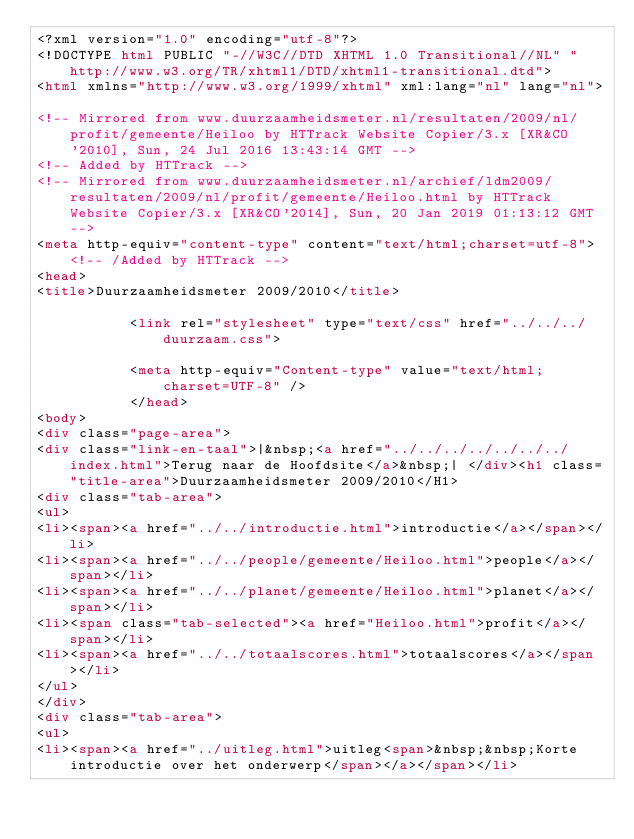<code> <loc_0><loc_0><loc_500><loc_500><_HTML_><?xml version="1.0" encoding="utf-8"?>
<!DOCTYPE html PUBLIC "-//W3C//DTD XHTML 1.0 Transitional//NL" "http://www.w3.org/TR/xhtml1/DTD/xhtml1-transitional.dtd">
<html xmlns="http://www.w3.org/1999/xhtml" xml:lang="nl" lang="nl">

<!-- Mirrored from www.duurzaamheidsmeter.nl/resultaten/2009/nl/profit/gemeente/Heiloo by HTTrack Website Copier/3.x [XR&CO'2010], Sun, 24 Jul 2016 13:43:14 GMT -->
<!-- Added by HTTrack -->
<!-- Mirrored from www.duurzaamheidsmeter.nl/archief/ldm2009/resultaten/2009/nl/profit/gemeente/Heiloo.html by HTTrack Website Copier/3.x [XR&CO'2014], Sun, 20 Jan 2019 01:13:12 GMT -->
<meta http-equiv="content-type" content="text/html;charset=utf-8"><!-- /Added by HTTrack -->
<head>
<title>Duurzaamheidsmeter 2009/2010</title>

           <link rel="stylesheet" type="text/css" href="../../../duurzaam.css">

           <meta http-equiv="Content-type" value="text/html; charset=UTF-8" />
           </head>
<body>
<div class="page-area">
<div class="link-en-taal">|&nbsp;<a href="../../../../../../../index.html">Terug naar de Hoofdsite</a>&nbsp;| </div><h1 class="title-area">Duurzaamheidsmeter 2009/2010</H1>
<div class="tab-area">
<ul>
<li><span><a href="../../introductie.html">introductie</a></span></li>
<li><span><a href="../../people/gemeente/Heiloo.html">people</a></span></li>
<li><span><a href="../../planet/gemeente/Heiloo.html">planet</a></span></li>
<li><span class="tab-selected"><a href="Heiloo.html">profit</a></span></li>
<li><span><a href="../../totaalscores.html">totaalscores</a></span></li>
</ul>
</div>
<div class="tab-area">
<ul>
<li><span><a href="../uitleg.html">uitleg<span>&nbsp;&nbsp;Korte introductie over het onderwerp</span></a></span></li></code> 